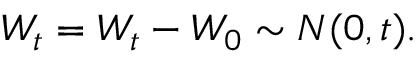Convert formula to latex. <formula><loc_0><loc_0><loc_500><loc_500>W _ { t } = W _ { t } - W _ { 0 } \sim N ( 0 , t ) .</formula> 